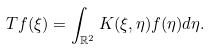<formula> <loc_0><loc_0><loc_500><loc_500>T f ( \xi ) = \int _ { \mathbb { R } ^ { 2 } } K ( \xi , \eta ) f ( \eta ) d \eta .</formula> 